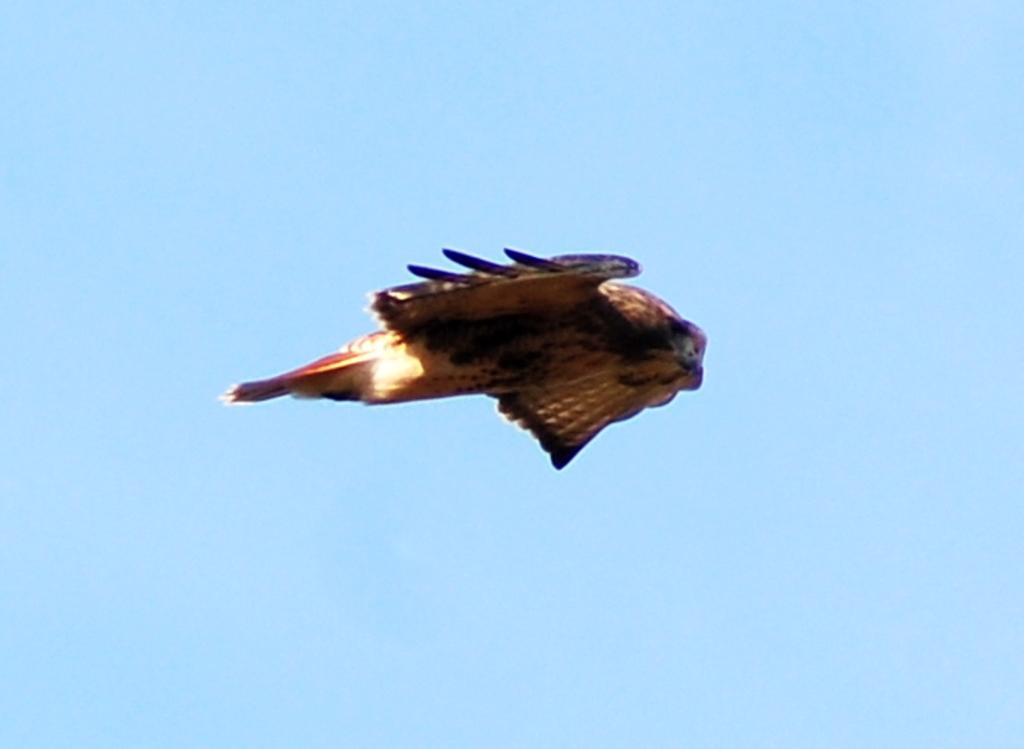What animal is featured in the image? There is an eagle in the image. What is the eagle doing in the image? The eagle is flying in the air. What color is the eagle in the image? The eagle is brown in color. What is the background of the image? The image depicts the sky. Where is the playground located in the image? There is no playground present in the image; it features an eagle flying in the sky. How many people are in the crowd depicted in the image? There is no crowd present in the image; it features an eagle flying in the sky. 